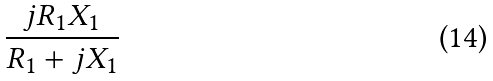<formula> <loc_0><loc_0><loc_500><loc_500>\frac { j R _ { 1 } X _ { 1 } } { R _ { 1 } + j X _ { 1 } }</formula> 